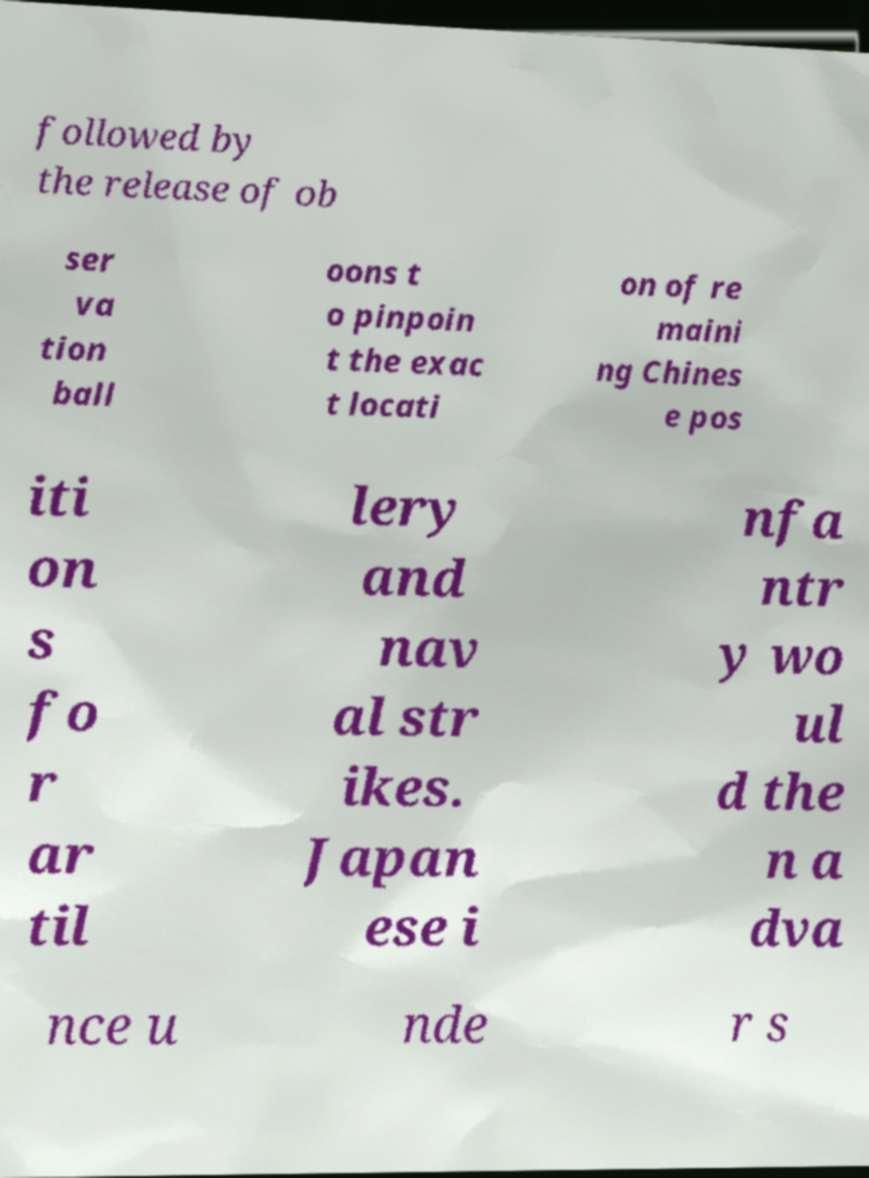Could you assist in decoding the text presented in this image and type it out clearly? followed by the release of ob ser va tion ball oons t o pinpoin t the exac t locati on of re maini ng Chines e pos iti on s fo r ar til lery and nav al str ikes. Japan ese i nfa ntr y wo ul d the n a dva nce u nde r s 